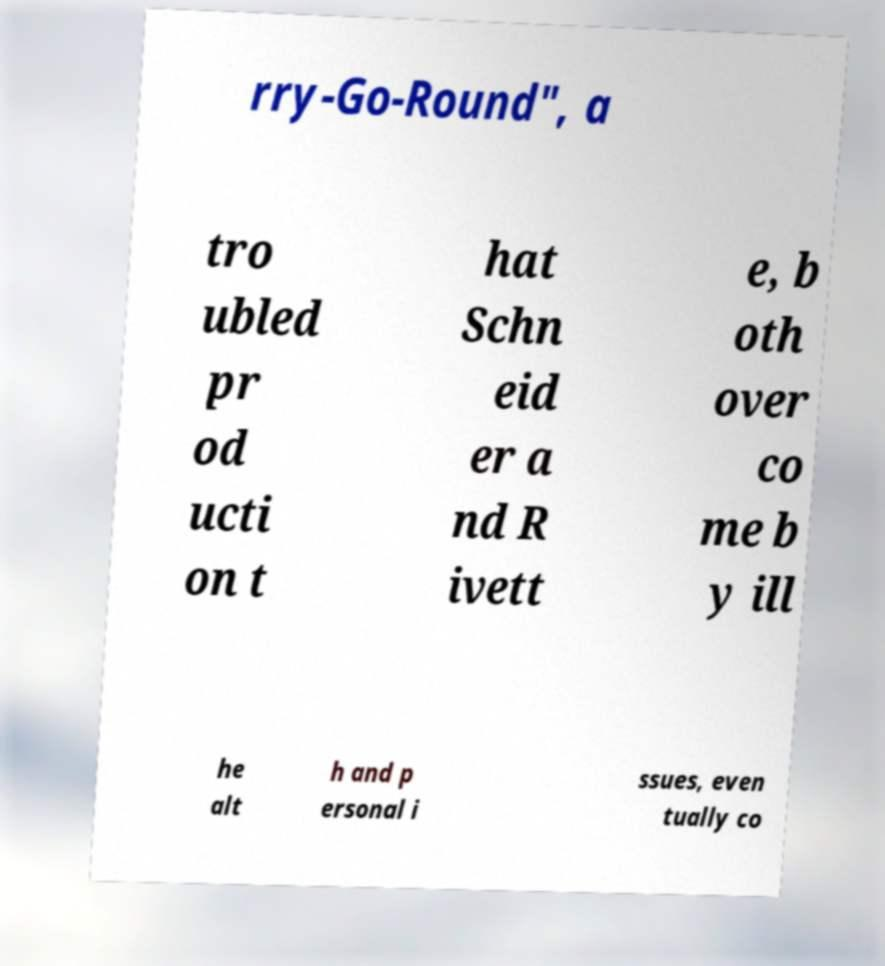Could you extract and type out the text from this image? rry-Go-Round", a tro ubled pr od ucti on t hat Schn eid er a nd R ivett e, b oth over co me b y ill he alt h and p ersonal i ssues, even tually co 